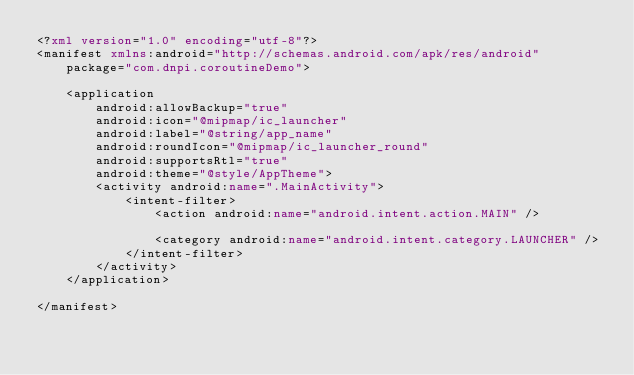<code> <loc_0><loc_0><loc_500><loc_500><_XML_><?xml version="1.0" encoding="utf-8"?>
<manifest xmlns:android="http://schemas.android.com/apk/res/android"
    package="com.dnpi.coroutineDemo">

    <application
        android:allowBackup="true"
        android:icon="@mipmap/ic_launcher"
        android:label="@string/app_name"
        android:roundIcon="@mipmap/ic_launcher_round"
        android:supportsRtl="true"
        android:theme="@style/AppTheme">
        <activity android:name=".MainActivity">
            <intent-filter>
                <action android:name="android.intent.action.MAIN" />

                <category android:name="android.intent.category.LAUNCHER" />
            </intent-filter>
        </activity>
    </application>

</manifest></code> 